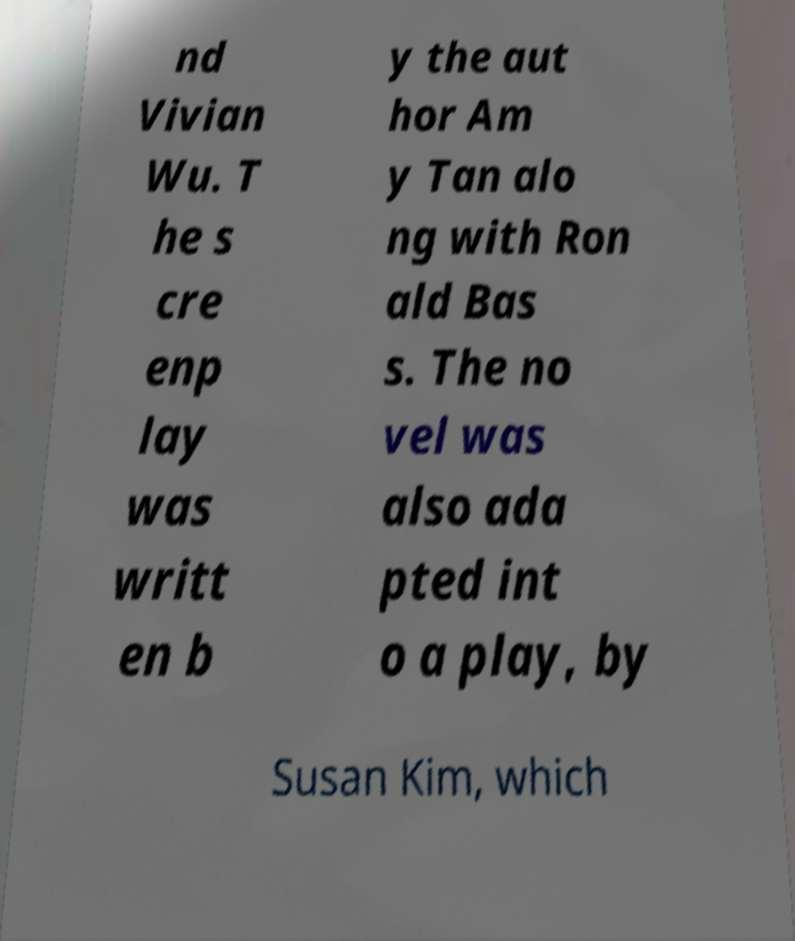Could you assist in decoding the text presented in this image and type it out clearly? nd Vivian Wu. T he s cre enp lay was writt en b y the aut hor Am y Tan alo ng with Ron ald Bas s. The no vel was also ada pted int o a play, by Susan Kim, which 